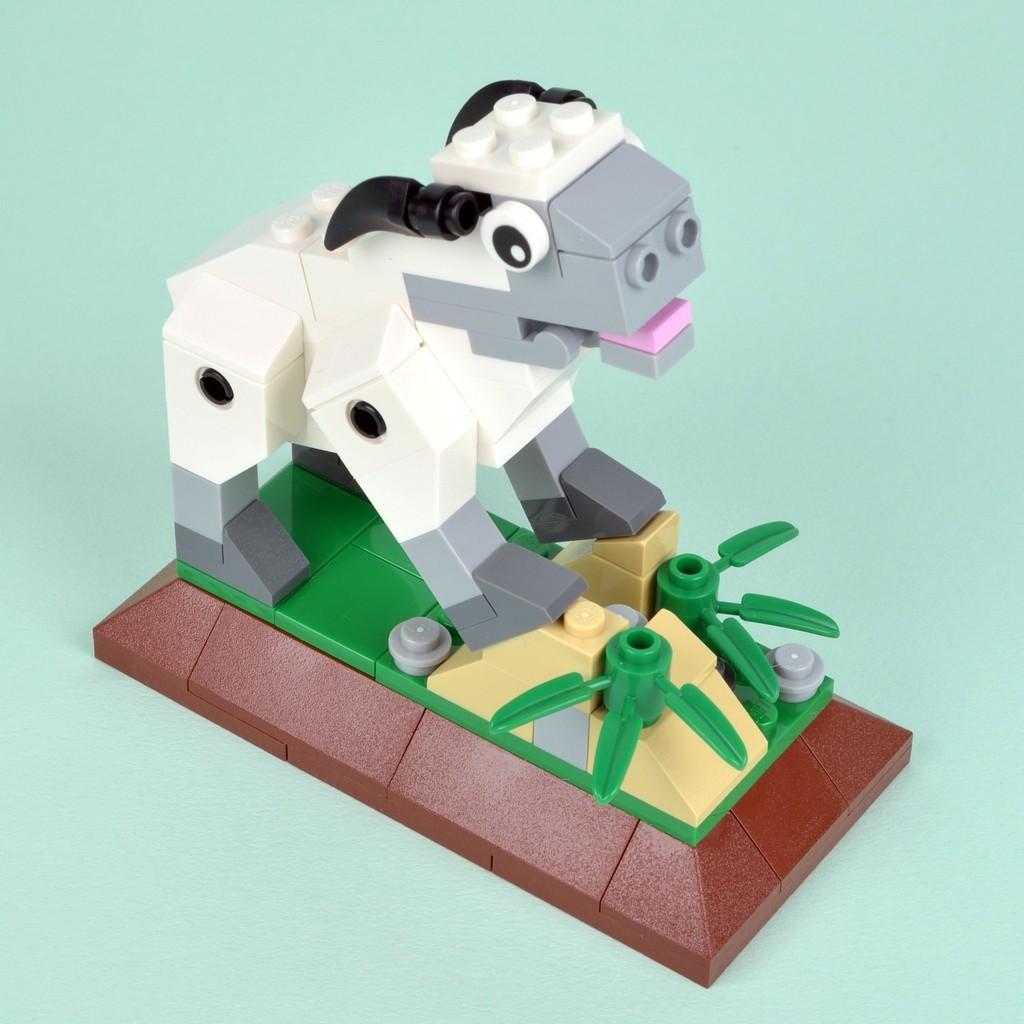Can you describe this image briefly? Here we can see an animal standing on a platform and some other objects on it made with lego toys on a platform. 